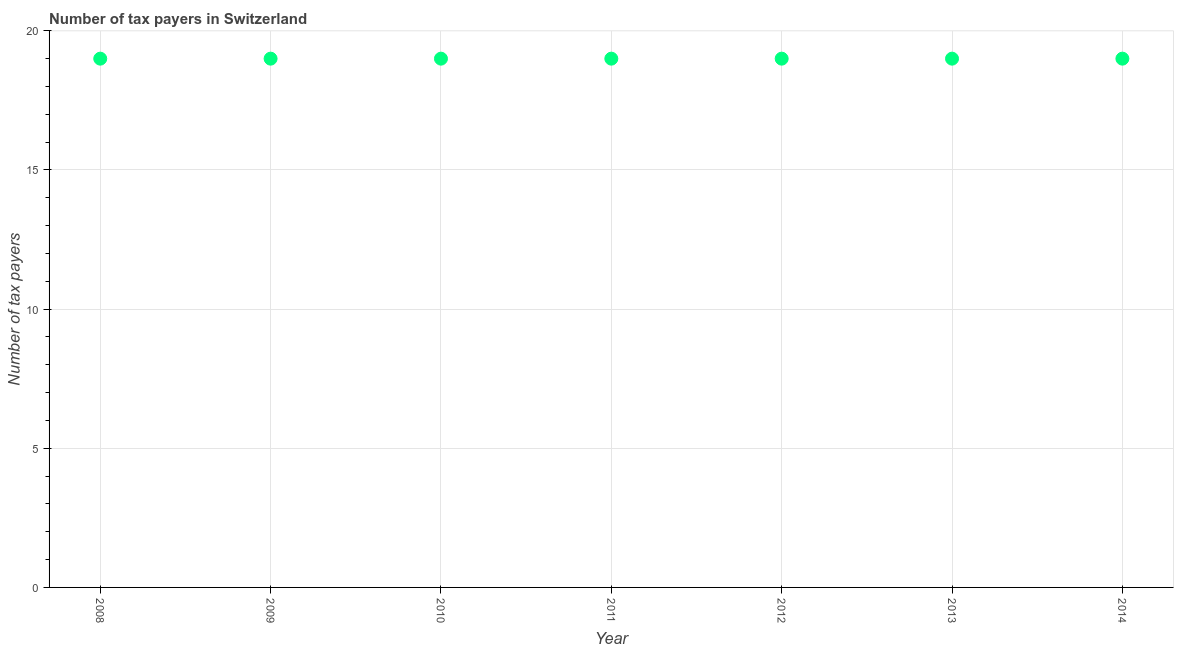What is the number of tax payers in 2014?
Your answer should be very brief. 19. Across all years, what is the maximum number of tax payers?
Offer a terse response. 19. Across all years, what is the minimum number of tax payers?
Keep it short and to the point. 19. In which year was the number of tax payers minimum?
Make the answer very short. 2008. What is the sum of the number of tax payers?
Give a very brief answer. 133. What is the difference between the number of tax payers in 2008 and 2011?
Your answer should be very brief. 0. What is the average number of tax payers per year?
Provide a short and direct response. 19. In how many years, is the number of tax payers greater than 18 ?
Give a very brief answer. 7. Is the number of tax payers in 2009 less than that in 2012?
Give a very brief answer. No. Is the difference between the number of tax payers in 2010 and 2014 greater than the difference between any two years?
Ensure brevity in your answer.  Yes. Is the sum of the number of tax payers in 2009 and 2011 greater than the maximum number of tax payers across all years?
Give a very brief answer. Yes. In how many years, is the number of tax payers greater than the average number of tax payers taken over all years?
Provide a short and direct response. 0. Does the number of tax payers monotonically increase over the years?
Provide a succinct answer. No. How many years are there in the graph?
Provide a short and direct response. 7. What is the difference between two consecutive major ticks on the Y-axis?
Provide a short and direct response. 5. Are the values on the major ticks of Y-axis written in scientific E-notation?
Offer a terse response. No. Does the graph contain any zero values?
Your answer should be compact. No. What is the title of the graph?
Keep it short and to the point. Number of tax payers in Switzerland. What is the label or title of the Y-axis?
Your answer should be compact. Number of tax payers. What is the Number of tax payers in 2008?
Give a very brief answer. 19. What is the Number of tax payers in 2011?
Provide a short and direct response. 19. What is the Number of tax payers in 2012?
Make the answer very short. 19. What is the Number of tax payers in 2014?
Your answer should be very brief. 19. What is the difference between the Number of tax payers in 2008 and 2009?
Your response must be concise. 0. What is the difference between the Number of tax payers in 2008 and 2010?
Your response must be concise. 0. What is the difference between the Number of tax payers in 2008 and 2012?
Your response must be concise. 0. What is the difference between the Number of tax payers in 2009 and 2011?
Ensure brevity in your answer.  0. What is the difference between the Number of tax payers in 2009 and 2013?
Make the answer very short. 0. What is the difference between the Number of tax payers in 2009 and 2014?
Keep it short and to the point. 0. What is the difference between the Number of tax payers in 2011 and 2014?
Give a very brief answer. 0. What is the difference between the Number of tax payers in 2012 and 2013?
Ensure brevity in your answer.  0. What is the ratio of the Number of tax payers in 2008 to that in 2009?
Offer a terse response. 1. What is the ratio of the Number of tax payers in 2008 to that in 2011?
Ensure brevity in your answer.  1. What is the ratio of the Number of tax payers in 2009 to that in 2010?
Your response must be concise. 1. What is the ratio of the Number of tax payers in 2009 to that in 2014?
Your response must be concise. 1. What is the ratio of the Number of tax payers in 2010 to that in 2011?
Your answer should be very brief. 1. What is the ratio of the Number of tax payers in 2010 to that in 2012?
Ensure brevity in your answer.  1. What is the ratio of the Number of tax payers in 2011 to that in 2012?
Your response must be concise. 1. What is the ratio of the Number of tax payers in 2011 to that in 2013?
Ensure brevity in your answer.  1. What is the ratio of the Number of tax payers in 2011 to that in 2014?
Provide a succinct answer. 1. What is the ratio of the Number of tax payers in 2012 to that in 2014?
Offer a very short reply. 1. 